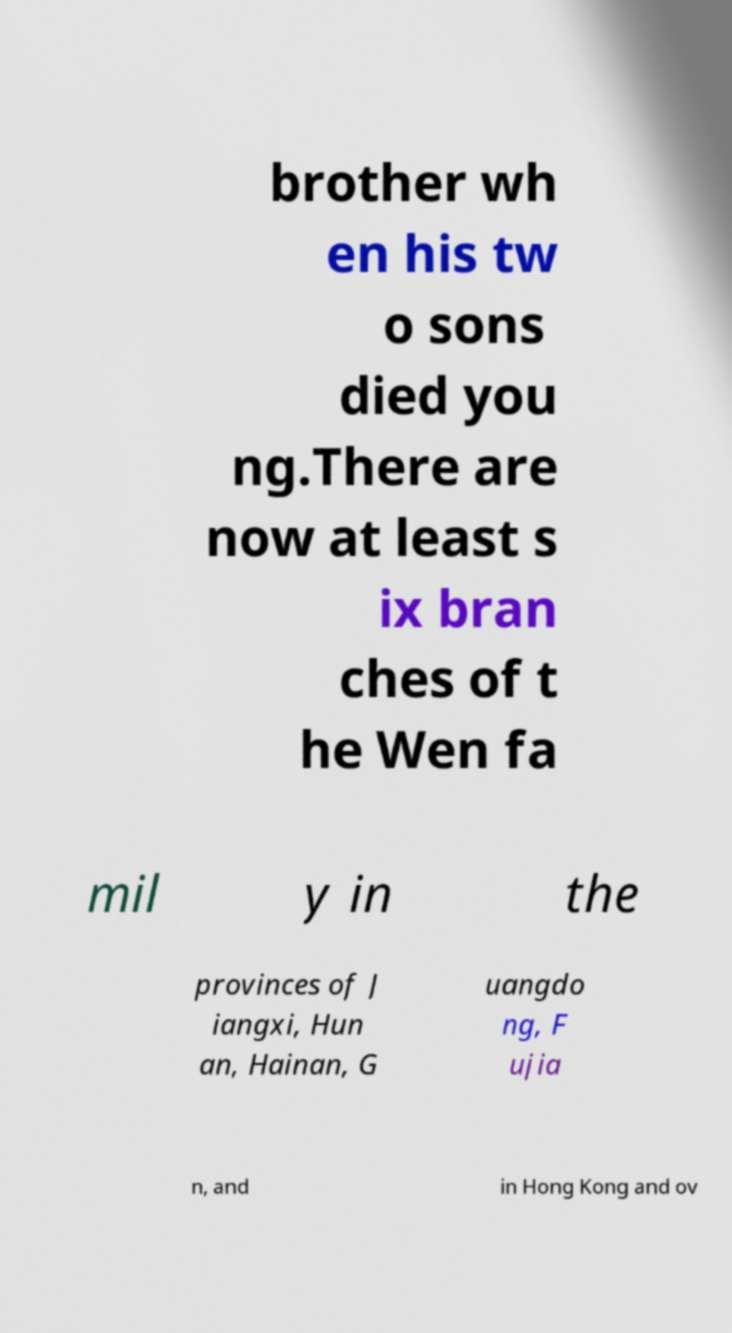Could you extract and type out the text from this image? brother wh en his tw o sons died you ng.There are now at least s ix bran ches of t he Wen fa mil y in the provinces of J iangxi, Hun an, Hainan, G uangdo ng, F ujia n, and in Hong Kong and ov 